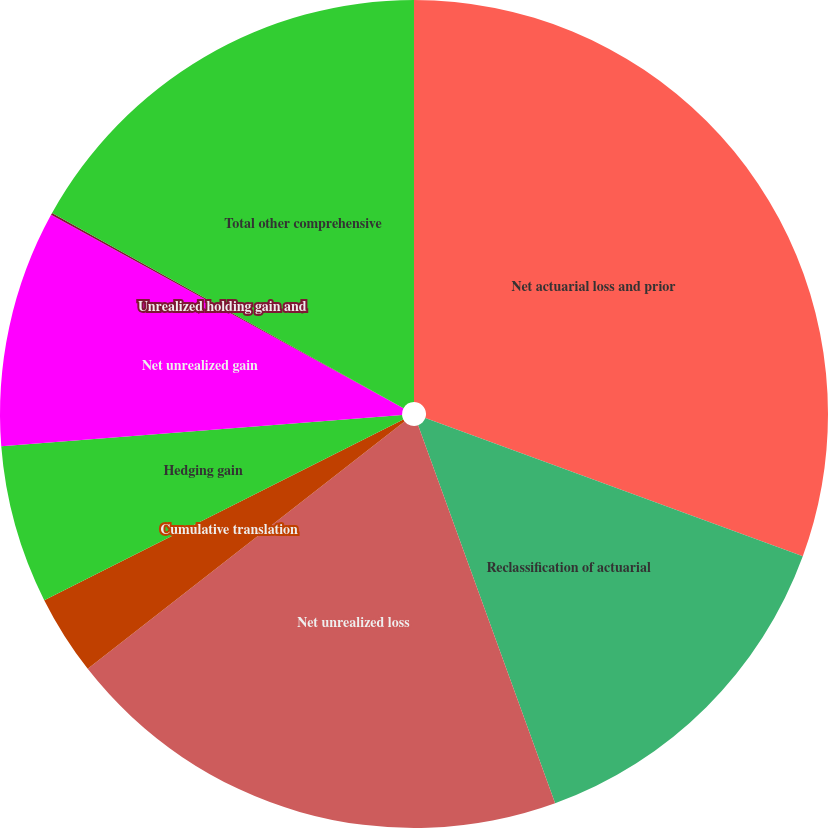Convert chart. <chart><loc_0><loc_0><loc_500><loc_500><pie_chart><fcel>Net actuarial loss and prior<fcel>Reclassification of actuarial<fcel>Net unrealized loss<fcel>Cumulative translation<fcel>Hedging gain<fcel>Net unrealized gain<fcel>Unrealized holding gain and<fcel>Total other comprehensive<nl><fcel>30.58%<fcel>13.88%<fcel>19.98%<fcel>3.13%<fcel>6.18%<fcel>9.23%<fcel>0.08%<fcel>16.93%<nl></chart> 